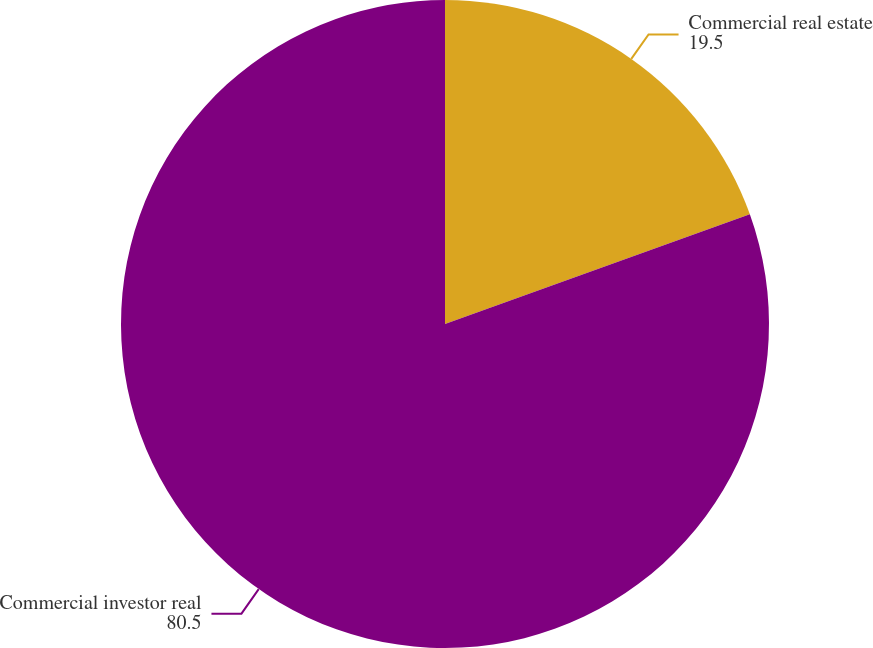Convert chart to OTSL. <chart><loc_0><loc_0><loc_500><loc_500><pie_chart><fcel>Commercial real estate<fcel>Commercial investor real<nl><fcel>19.5%<fcel>80.5%<nl></chart> 